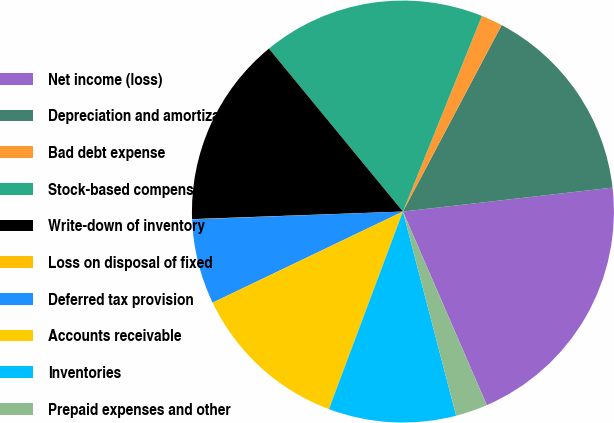Convert chart. <chart><loc_0><loc_0><loc_500><loc_500><pie_chart><fcel>Net income (loss)<fcel>Depreciation and amortization<fcel>Bad debt expense<fcel>Stock-based compensation<fcel>Write-down of inventory<fcel>Loss on disposal of fixed<fcel>Deferred tax provision<fcel>Accounts receivable<fcel>Inventories<fcel>Prepaid expenses and other<nl><fcel>20.3%<fcel>15.44%<fcel>1.64%<fcel>17.06%<fcel>14.62%<fcel>0.02%<fcel>6.51%<fcel>12.19%<fcel>9.76%<fcel>2.45%<nl></chart> 